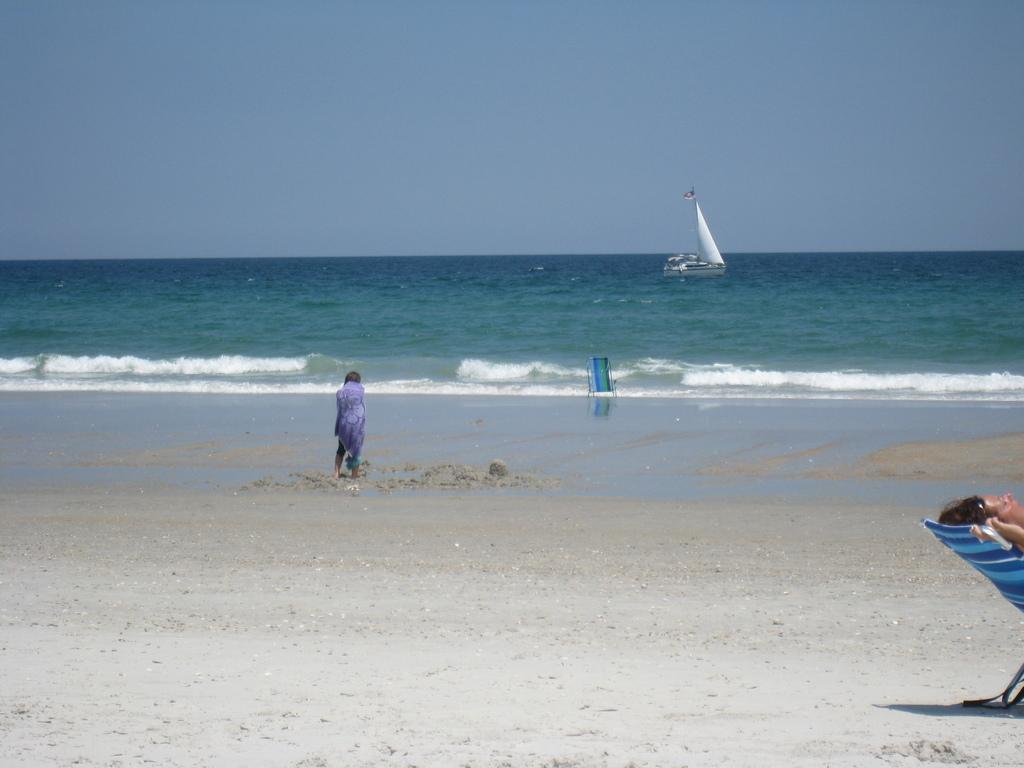In one or two sentences, can you explain what this image depicts? In this image, we can see a person is standing on the sand. Background we can see a boat is sailing on the water. Here there is a chair. Top of the image, we can see the sky. On the right side of the image, we can see a person is on the chair. 